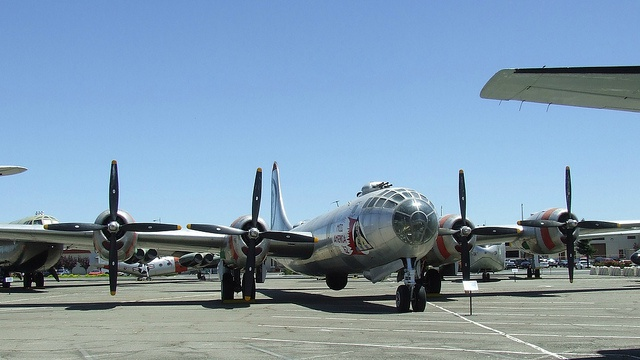Describe the objects in this image and their specific colors. I can see airplane in darkgray, black, and gray tones, airplane in gray, black, darkgray, and lightgray tones, airplane in darkgray, black, gray, and lightgray tones, airplane in gray, black, white, and darkgray tones, and airplane in darkgray, black, gray, and purple tones in this image. 